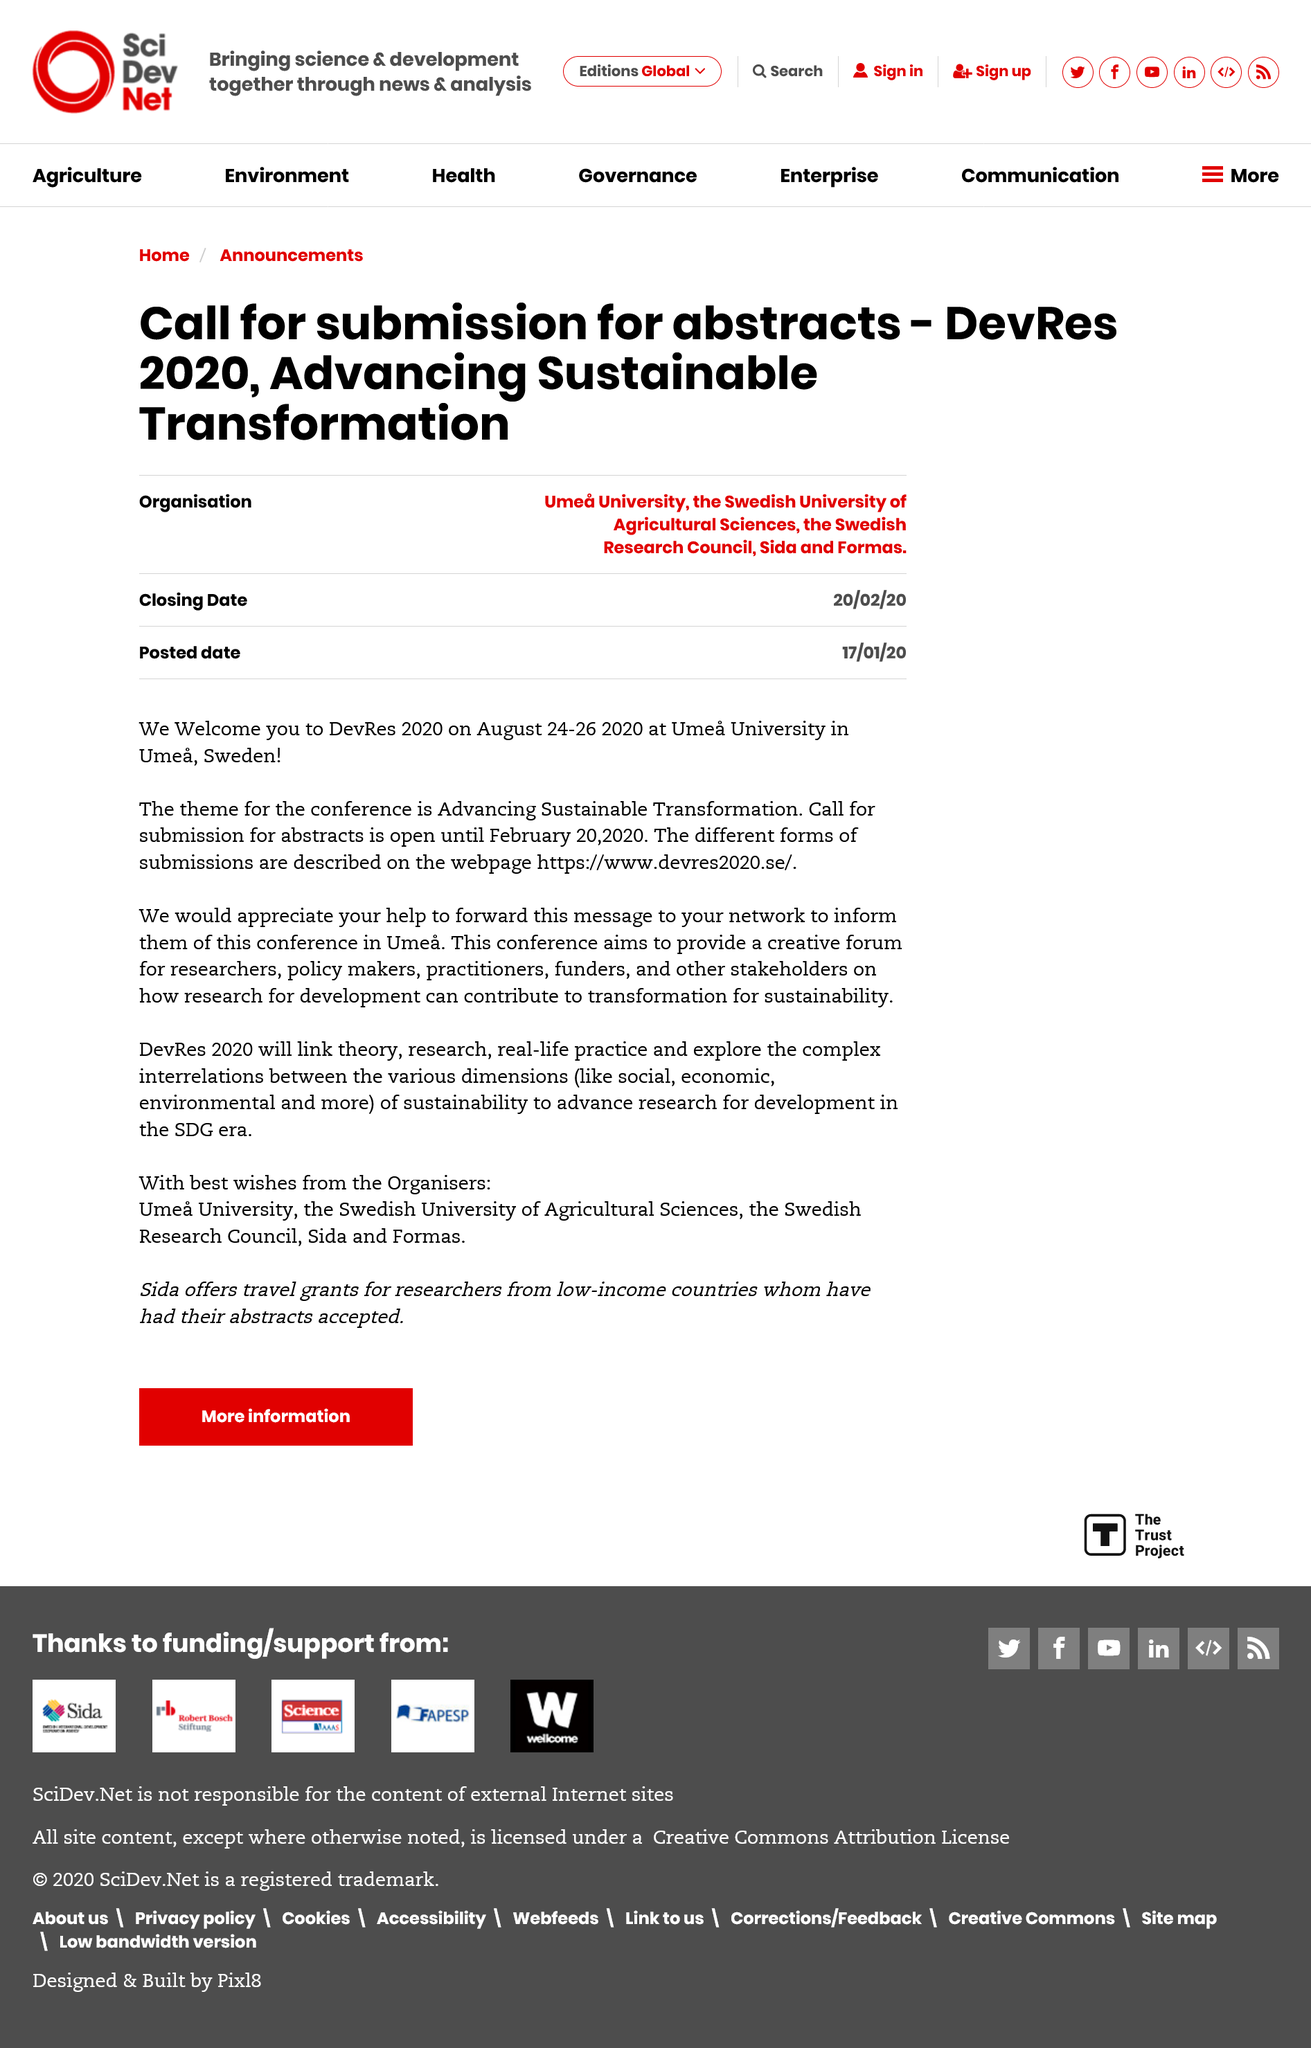Indicate a few pertinent items in this graphic. The submission of extracts is due on February 20, 2020. The theme for the conference is Advancing Sustainable Transformation, with the goal of promoting the use of sustainable practices to improve the well-being of individuals and communities. The conference will be held at Umea University in Umea, Sweden. 